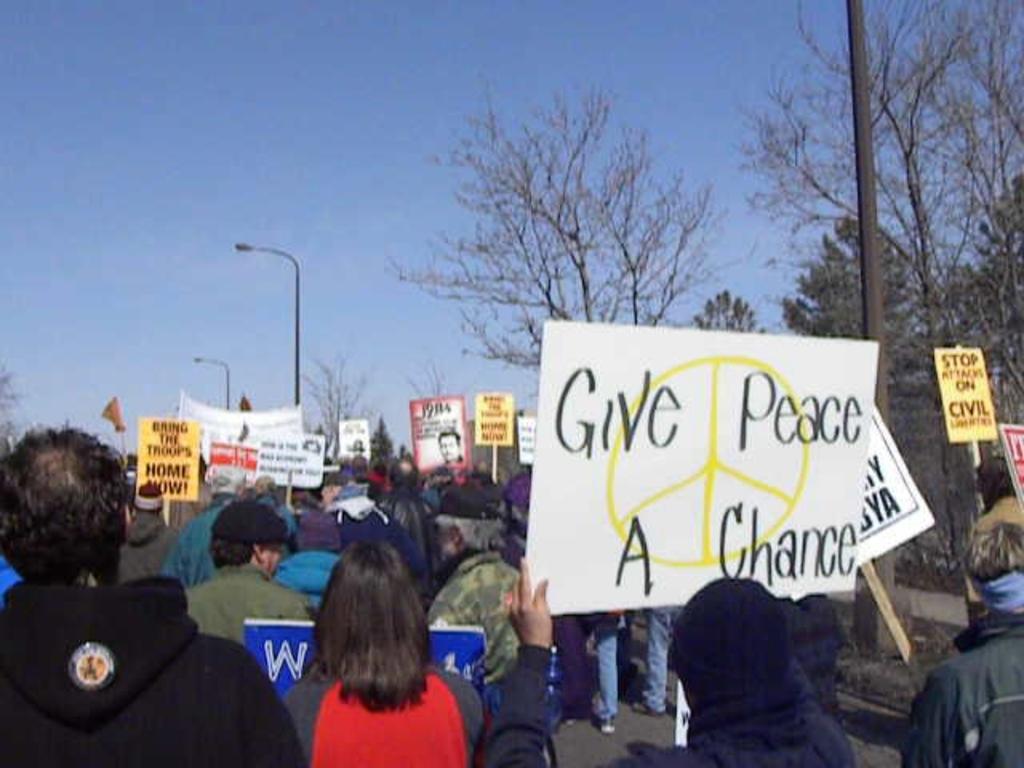Give peace a chance?
Your answer should be compact. Yes. 